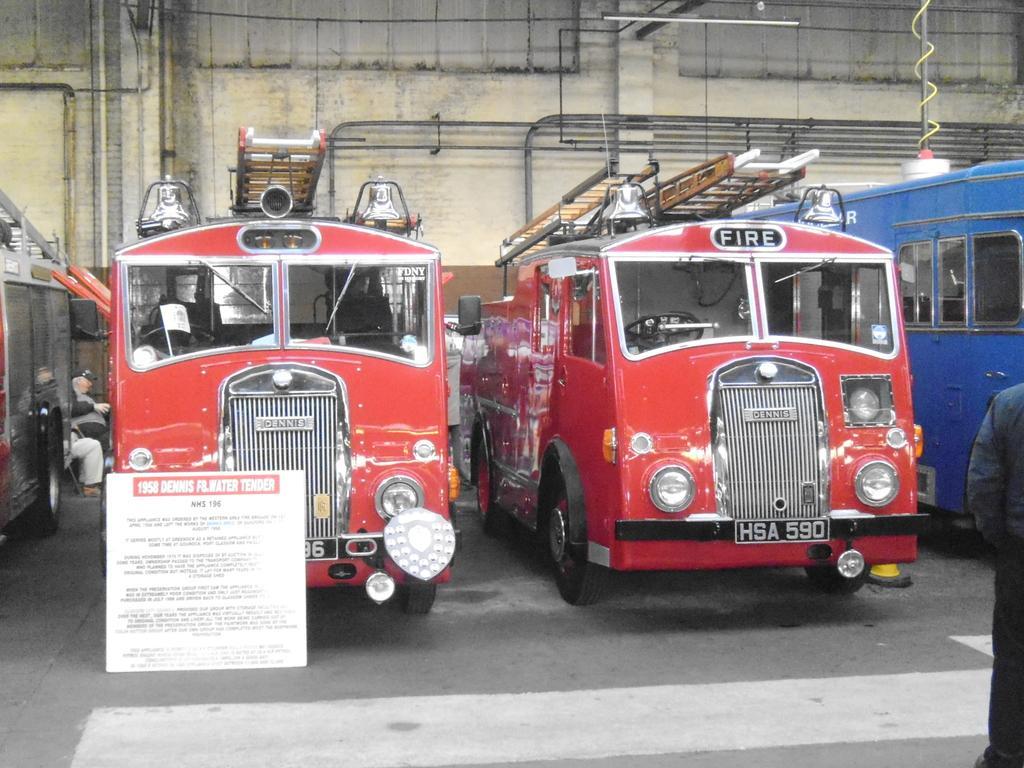Could you give a brief overview of what you see in this image? In this image I can see many vehicles which are in red and blue color. There are ladders on three vehicles. There is a board in-front of these vehicles and something is written on it. In the background I can see the pipes and wall. To the right I can see the person standing. 